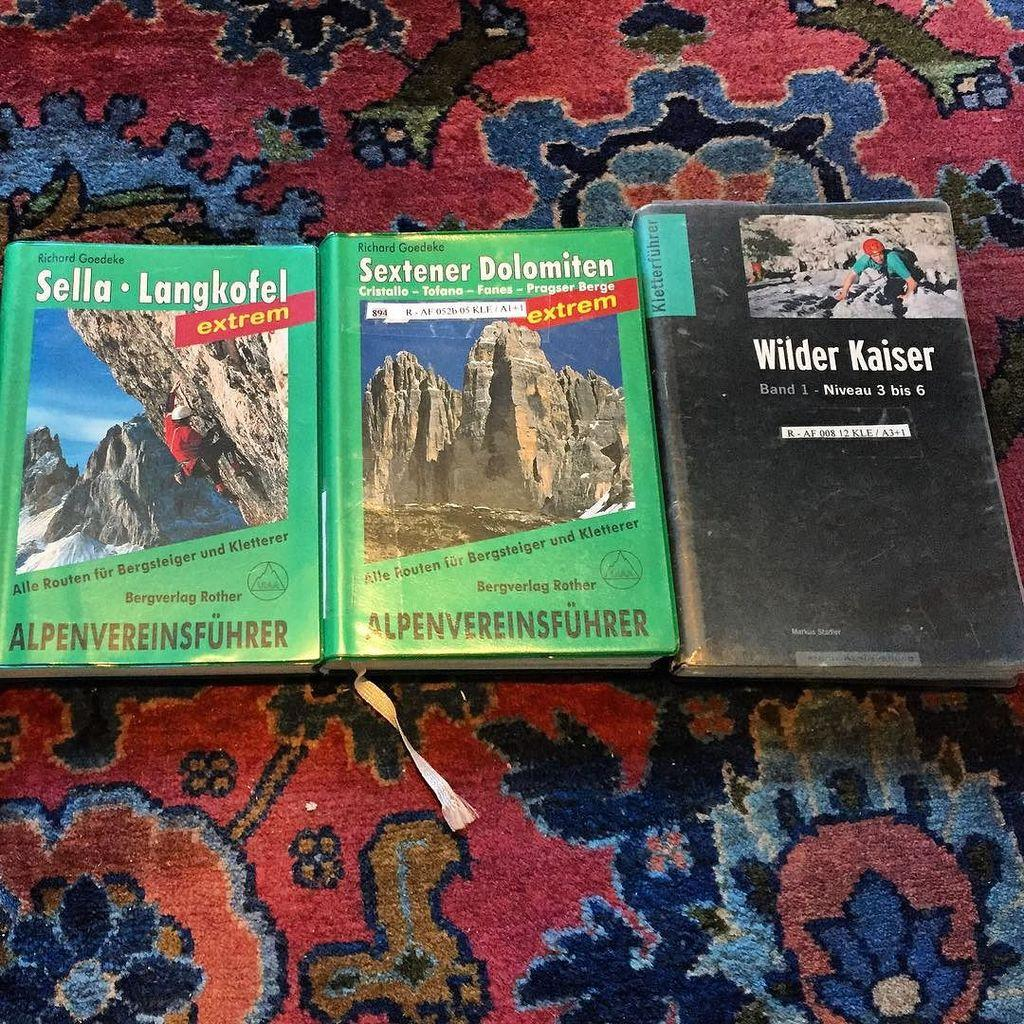<image>
Create a compact narrative representing the image presented. Three books, the last of which is titled Wilder Kaiser. 